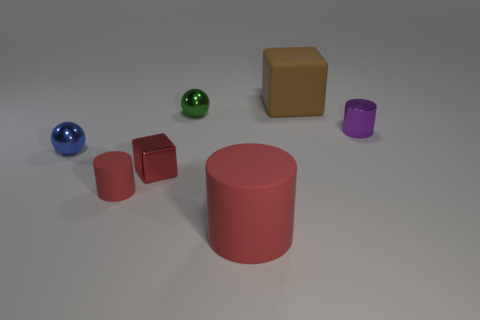Which objects in the image are closest to the large red cylinder? The objects closest to the large red cylinder appear to be the two small red cubes situated to its left. 